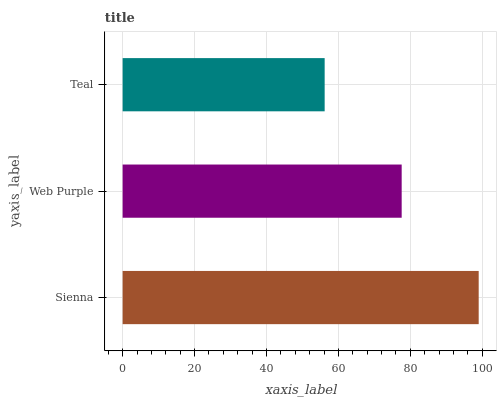Is Teal the minimum?
Answer yes or no. Yes. Is Sienna the maximum?
Answer yes or no. Yes. Is Web Purple the minimum?
Answer yes or no. No. Is Web Purple the maximum?
Answer yes or no. No. Is Sienna greater than Web Purple?
Answer yes or no. Yes. Is Web Purple less than Sienna?
Answer yes or no. Yes. Is Web Purple greater than Sienna?
Answer yes or no. No. Is Sienna less than Web Purple?
Answer yes or no. No. Is Web Purple the high median?
Answer yes or no. Yes. Is Web Purple the low median?
Answer yes or no. Yes. Is Sienna the high median?
Answer yes or no. No. Is Teal the low median?
Answer yes or no. No. 